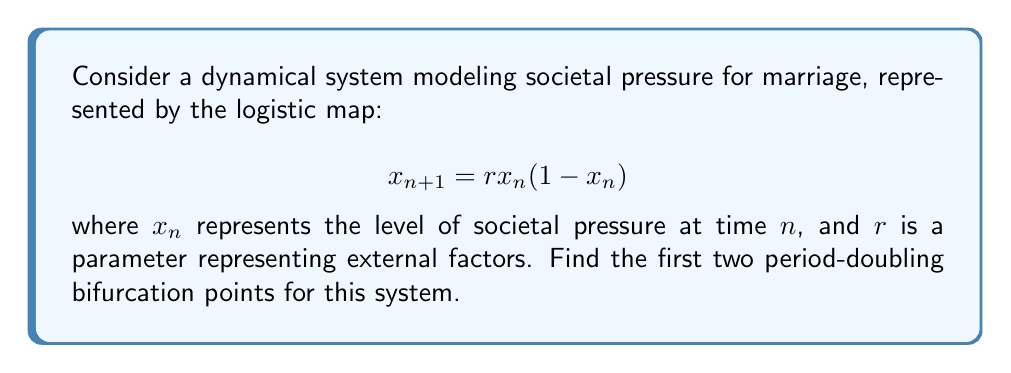What is the answer to this math problem? 1) The logistic map undergoes period-doubling bifurcations as $r$ increases. To find these points, we need to analyze the stability of fixed points and period-2 cycles.

2) First, let's find the fixed points. Set $x_{n+1} = x_n = x^*$:
   $$x^* = rx^*(1-x^*)$$
   Solving this, we get $x^* = 0$ or $x^* = 1 - \frac{1}{r}$

3) The non-zero fixed point is stable when $|\frac{d}{dx}(rx(1-x))| < 1$ at $x = 1 - \frac{1}{r}$:
   $$|r(1-2x^*)| < 1$$
   $$|2-r| < 1$$
   $$1 < r < 3$$

4) The first period-doubling bifurcation occurs when $r = 3$.

5) For the second bifurcation, we need to find when the period-2 cycle becomes unstable. The period-2 cycle satisfies:
   $$x_1 = rx_2(1-x_2)$$
   $$x_2 = rx_1(1-x_1)$$

6) The stability of this cycle is determined by the product of derivatives:
   $$|\frac{d}{dx}(rx_1(1-x_1)) \cdot \frac{d}{dx}(rx_2(1-x_2))| < 1$$
   $$|r^2(1-2x_1)(1-2x_2)| < 1$$

7) Solving this numerically (as an exact solution is complex), we find that the second period-doubling bifurcation occurs at approximately $r \approx 3.449$.
Answer: $r_1 = 3$, $r_2 \approx 3.449$ 